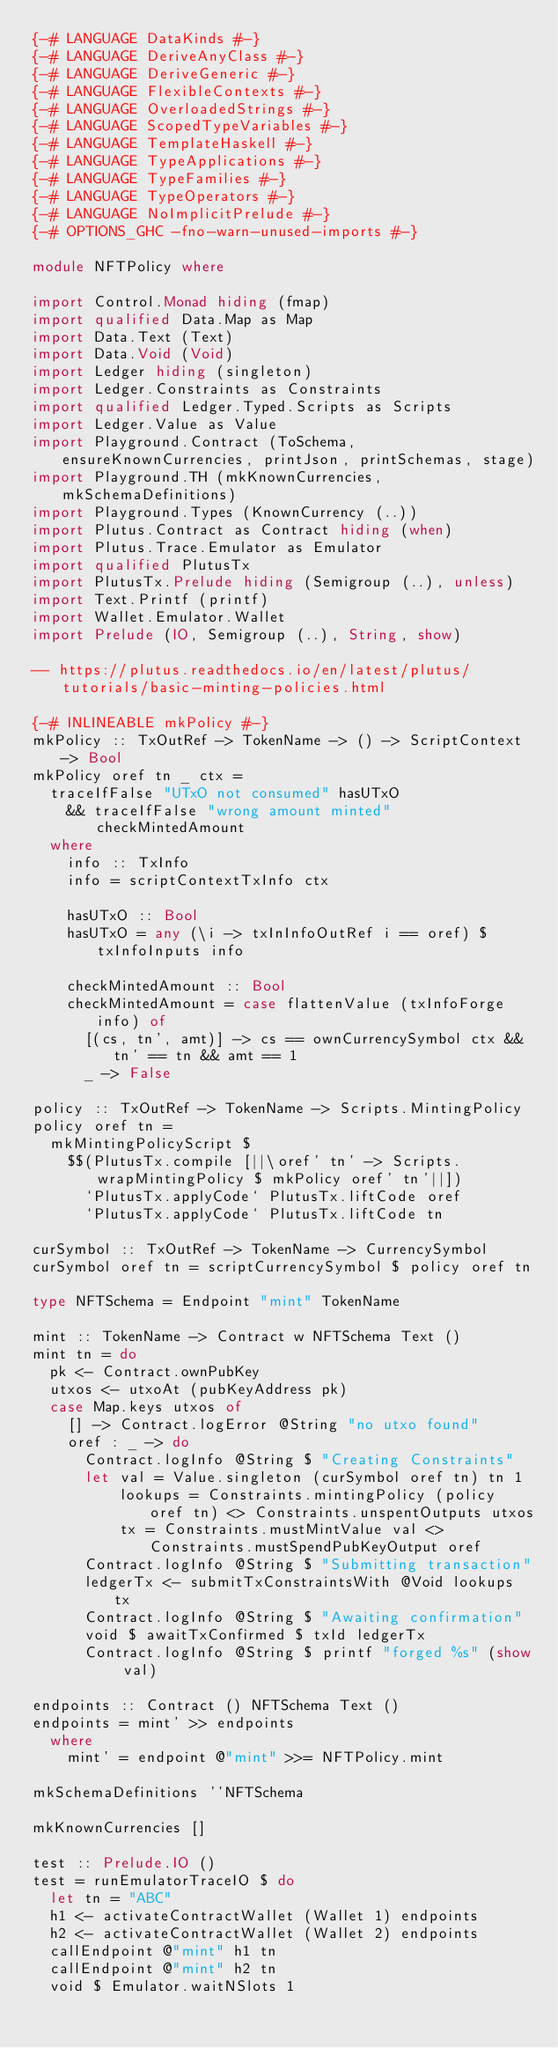Convert code to text. <code><loc_0><loc_0><loc_500><loc_500><_Haskell_>{-# LANGUAGE DataKinds #-}
{-# LANGUAGE DeriveAnyClass #-}
{-# LANGUAGE DeriveGeneric #-}
{-# LANGUAGE FlexibleContexts #-}
{-# LANGUAGE OverloadedStrings #-}
{-# LANGUAGE ScopedTypeVariables #-}
{-# LANGUAGE TemplateHaskell #-}
{-# LANGUAGE TypeApplications #-}
{-# LANGUAGE TypeFamilies #-}
{-# LANGUAGE TypeOperators #-}
{-# LANGUAGE NoImplicitPrelude #-}
{-# OPTIONS_GHC -fno-warn-unused-imports #-}

module NFTPolicy where

import Control.Monad hiding (fmap)
import qualified Data.Map as Map
import Data.Text (Text)
import Data.Void (Void)
import Ledger hiding (singleton)
import Ledger.Constraints as Constraints
import qualified Ledger.Typed.Scripts as Scripts
import Ledger.Value as Value
import Playground.Contract (ToSchema, ensureKnownCurrencies, printJson, printSchemas, stage)
import Playground.TH (mkKnownCurrencies, mkSchemaDefinitions)
import Playground.Types (KnownCurrency (..))
import Plutus.Contract as Contract hiding (when)
import Plutus.Trace.Emulator as Emulator
import qualified PlutusTx
import PlutusTx.Prelude hiding (Semigroup (..), unless)
import Text.Printf (printf)
import Wallet.Emulator.Wallet
import Prelude (IO, Semigroup (..), String, show)

-- https://plutus.readthedocs.io/en/latest/plutus/tutorials/basic-minting-policies.html

{-# INLINEABLE mkPolicy #-}
mkPolicy :: TxOutRef -> TokenName -> () -> ScriptContext -> Bool
mkPolicy oref tn _ ctx =
  traceIfFalse "UTxO not consumed" hasUTxO
    && traceIfFalse "wrong amount minted" checkMintedAmount
  where
    info :: TxInfo
    info = scriptContextTxInfo ctx

    hasUTxO :: Bool
    hasUTxO = any (\i -> txInInfoOutRef i == oref) $ txInfoInputs info

    checkMintedAmount :: Bool
    checkMintedAmount = case flattenValue (txInfoForge info) of
      [(cs, tn', amt)] -> cs == ownCurrencySymbol ctx && tn' == tn && amt == 1
      _ -> False

policy :: TxOutRef -> TokenName -> Scripts.MintingPolicy
policy oref tn =
  mkMintingPolicyScript $
    $$(PlutusTx.compile [||\oref' tn' -> Scripts.wrapMintingPolicy $ mkPolicy oref' tn'||])
      `PlutusTx.applyCode` PlutusTx.liftCode oref
      `PlutusTx.applyCode` PlutusTx.liftCode tn

curSymbol :: TxOutRef -> TokenName -> CurrencySymbol
curSymbol oref tn = scriptCurrencySymbol $ policy oref tn

type NFTSchema = Endpoint "mint" TokenName

mint :: TokenName -> Contract w NFTSchema Text ()
mint tn = do
  pk <- Contract.ownPubKey
  utxos <- utxoAt (pubKeyAddress pk)
  case Map.keys utxos of
    [] -> Contract.logError @String "no utxo found"
    oref : _ -> do
      Contract.logInfo @String $ "Creating Constraints"
      let val = Value.singleton (curSymbol oref tn) tn 1
          lookups = Constraints.mintingPolicy (policy oref tn) <> Constraints.unspentOutputs utxos
          tx = Constraints.mustMintValue val <> Constraints.mustSpendPubKeyOutput oref
      Contract.logInfo @String $ "Submitting transaction"
      ledgerTx <- submitTxConstraintsWith @Void lookups tx
      Contract.logInfo @String $ "Awaiting confirmation"
      void $ awaitTxConfirmed $ txId ledgerTx
      Contract.logInfo @String $ printf "forged %s" (show val)

endpoints :: Contract () NFTSchema Text ()
endpoints = mint' >> endpoints
  where
    mint' = endpoint @"mint" >>= NFTPolicy.mint

mkSchemaDefinitions ''NFTSchema

mkKnownCurrencies []

test :: Prelude.IO ()
test = runEmulatorTraceIO $ do
  let tn = "ABC"
  h1 <- activateContractWallet (Wallet 1) endpoints
  h2 <- activateContractWallet (Wallet 2) endpoints
  callEndpoint @"mint" h1 tn
  callEndpoint @"mint" h2 tn
  void $ Emulator.waitNSlots 1
</code> 